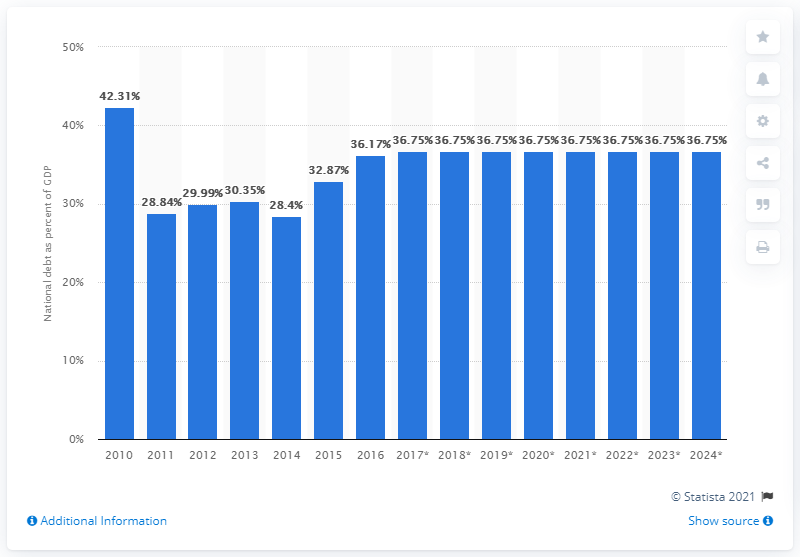Point out several critical features in this image. As of 2017 and beyond, the national debt of Norway is expected to account for approximately 36.75% of the country's Gross Domestic Product (GDP), according to projections. 